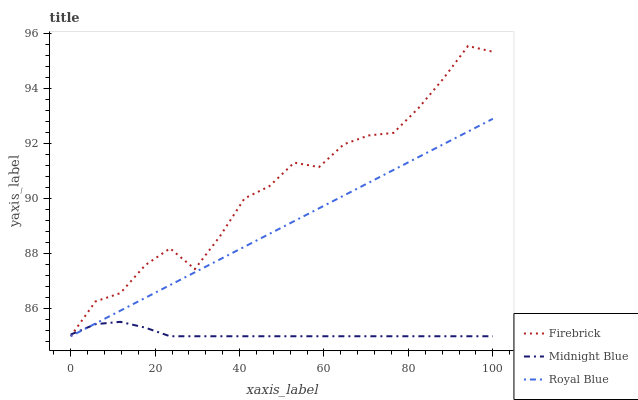Does Midnight Blue have the minimum area under the curve?
Answer yes or no. Yes. Does Firebrick have the maximum area under the curve?
Answer yes or no. Yes. Does Firebrick have the minimum area under the curve?
Answer yes or no. No. Does Midnight Blue have the maximum area under the curve?
Answer yes or no. No. Is Royal Blue the smoothest?
Answer yes or no. Yes. Is Firebrick the roughest?
Answer yes or no. Yes. Is Midnight Blue the smoothest?
Answer yes or no. No. Is Midnight Blue the roughest?
Answer yes or no. No. Does Royal Blue have the lowest value?
Answer yes or no. Yes. Does Firebrick have the highest value?
Answer yes or no. Yes. Does Midnight Blue have the highest value?
Answer yes or no. No. Does Firebrick intersect Midnight Blue?
Answer yes or no. Yes. Is Firebrick less than Midnight Blue?
Answer yes or no. No. Is Firebrick greater than Midnight Blue?
Answer yes or no. No. 